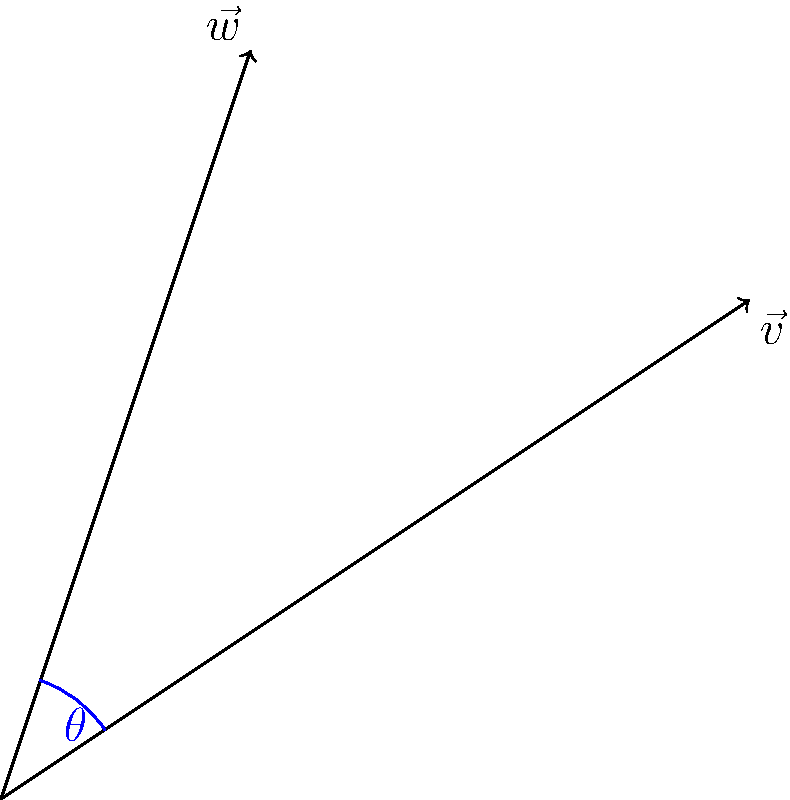In your fashion design work, you're analyzing two emerging trend vectors: $\vec{v} = (3,2)$ represents the resurgence of 1960s mod style, while $\vec{w} = (1,3)$ represents the revival of 1970s bohemian chic. Calculate the angle $\theta$ between these two trend vectors to determine how closely related these vintage inspirations are in your modern collection. To find the angle between two vectors, we can use the dot product formula:

1) The dot product formula: $\cos \theta = \frac{\vec{v} \cdot \vec{w}}{|\vec{v}||\vec{w}|}$

2) Calculate the dot product: $\vec{v} \cdot \vec{w} = (3)(1) + (2)(3) = 3 + 6 = 9$

3) Calculate the magnitudes:
   $|\vec{v}| = \sqrt{3^2 + 2^2} = \sqrt{13}$
   $|\vec{w}| = \sqrt{1^2 + 3^2} = \sqrt{10}$

4) Substitute into the formula:
   $\cos \theta = \frac{9}{\sqrt{13}\sqrt{10}}$

5) Simplify:
   $\cos \theta = \frac{9}{\sqrt{130}}$

6) Take the inverse cosine (arccos) of both sides:
   $\theta = \arccos(\frac{9}{\sqrt{130}})$

7) Calculate the result:
   $\theta \approx 0.5615$ radians

8) Convert to degrees:
   $\theta \approx 0.5615 \times \frac{180}{\pi} \approx 32.18°$
Answer: $32.18°$ 